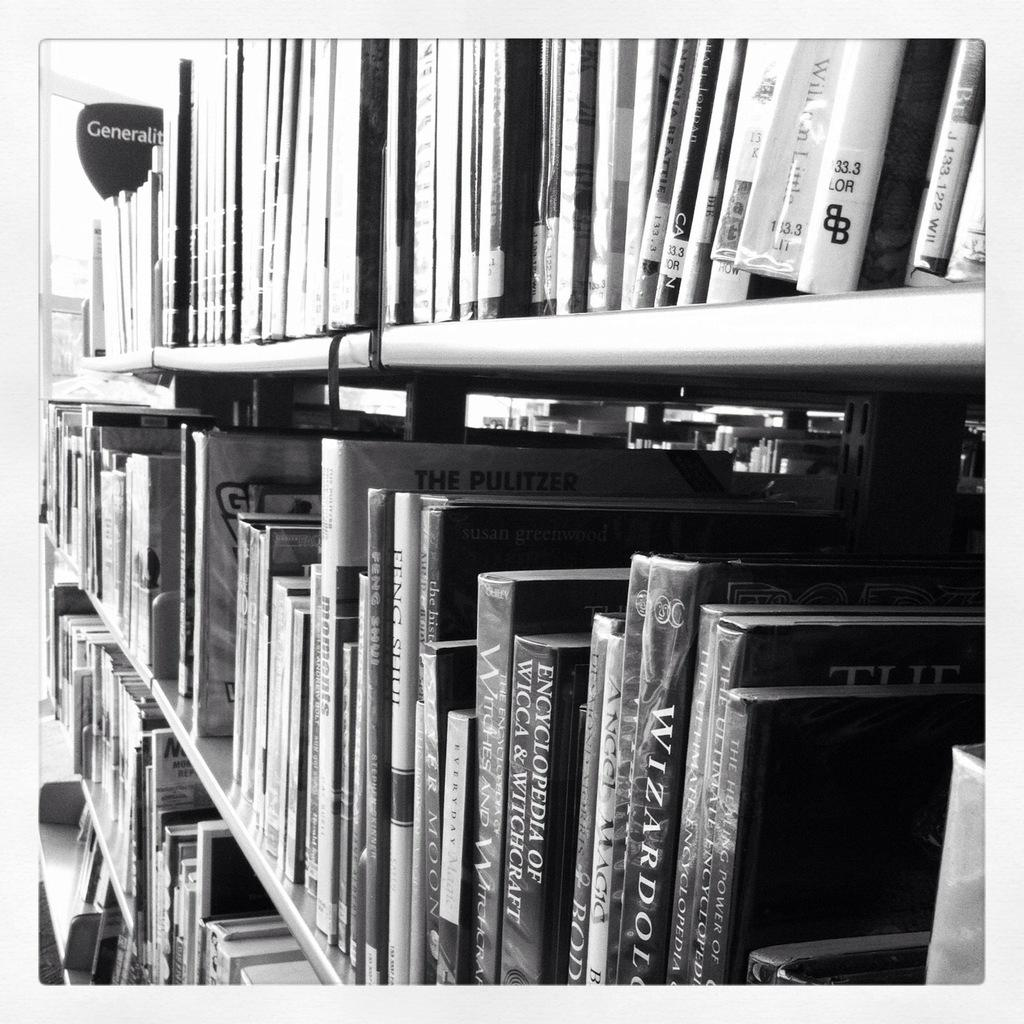Provide a one-sentence caption for the provided image. Book shelf that has a book titled "The Pulitzer". 